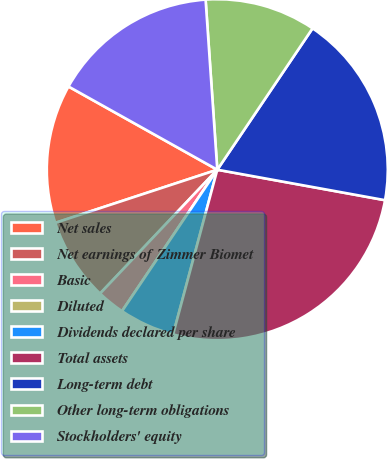Convert chart. <chart><loc_0><loc_0><loc_500><loc_500><pie_chart><fcel>Net sales<fcel>Net earnings of Zimmer Biomet<fcel>Basic<fcel>Diluted<fcel>Dividends declared per share<fcel>Total assets<fcel>Long-term debt<fcel>Other long-term obligations<fcel>Stockholders' equity<nl><fcel>13.16%<fcel>7.89%<fcel>2.63%<fcel>0.0%<fcel>5.26%<fcel>26.31%<fcel>18.42%<fcel>10.53%<fcel>15.79%<nl></chart> 